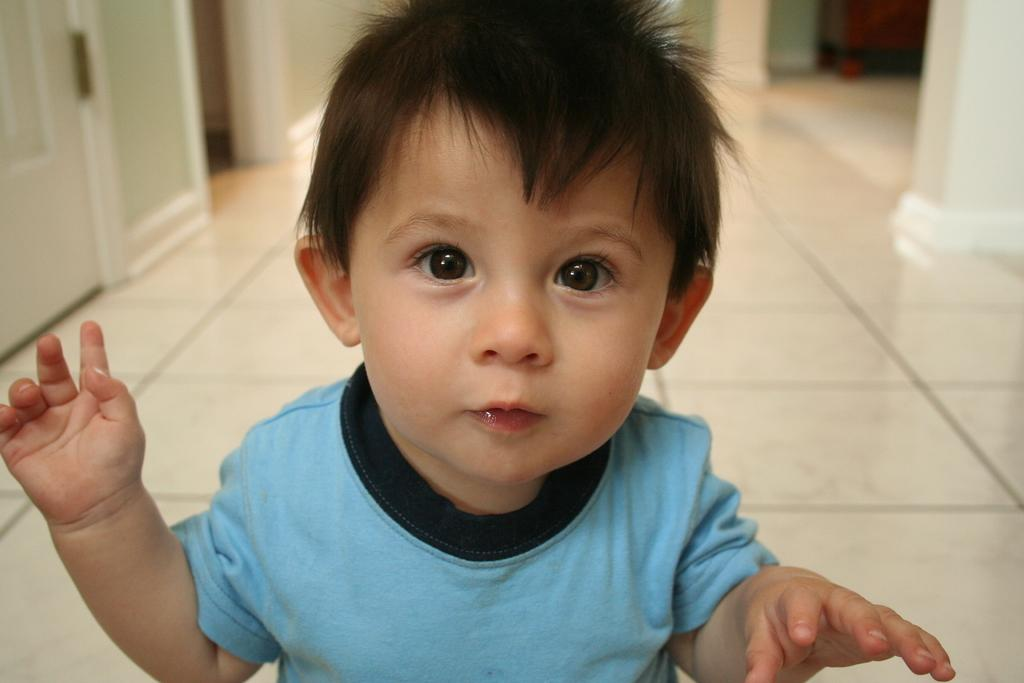Who is present in the image? There is a boy in the image. What is the boy wearing? The boy is wearing a blue t-shirt. What architectural features can be seen in the image? There is a door in the top left corner and a pillar in the top right corner of the image. What type of surface is visible in the image? There is a floor visible in the image. What type of nose can be seen on the boy in the image? There is no nose visible on the boy in the image, as it is a photograph and does not show the boy's face. --- Facts: 1. There is a car in the image. 2. The car is red. 3. The car has four wheels. 4. There is a road in the image. 5. There are trees in the background of the image. Absurd Topics: bird, hat, ocean Conversation: What is the main subject of the image? The main subject of the image is a car. What color is the car? The car is red. How many wheels does the car have? The car has four wheels. What type of surface is visible in the image? There is a road in the image. What can be seen in the background of the image? There are trees in the background of the image. Reasoning: Let's think step by step in order to produce the conversation. We start by identifying the main subject in the image, which is the car. Then, we expand the conversation to include details about the car's color and the number of wheels it has. Next, we mention the road as a significant element in the image. Finally, we describe the background, which includes trees. Each question is designed to elicit a specific detail about the image that is known from the provided facts. Absurd Question/Answer: Can you see any birds wearing hats in the image? There are no birds or hats present in the image. --- Facts: 1. There is a group of people in the image. 2. The people are wearing hats. 3. The hats are black. 4. There is a table in the image. 5. There are chairs around the table. Absurd Topics: elephant, rainbow, mountain Conversation: Who is present in the image? There is a group of people in the image. What are the people wearing on their heads? The people are wearing hats. What color are the hats? The hats are black. What type of furniture is visible in the image? There is a table and chairs around the table in the image. Reasoning: Let's think step by step in order to produce the conversation. We start by identifying the main subject 